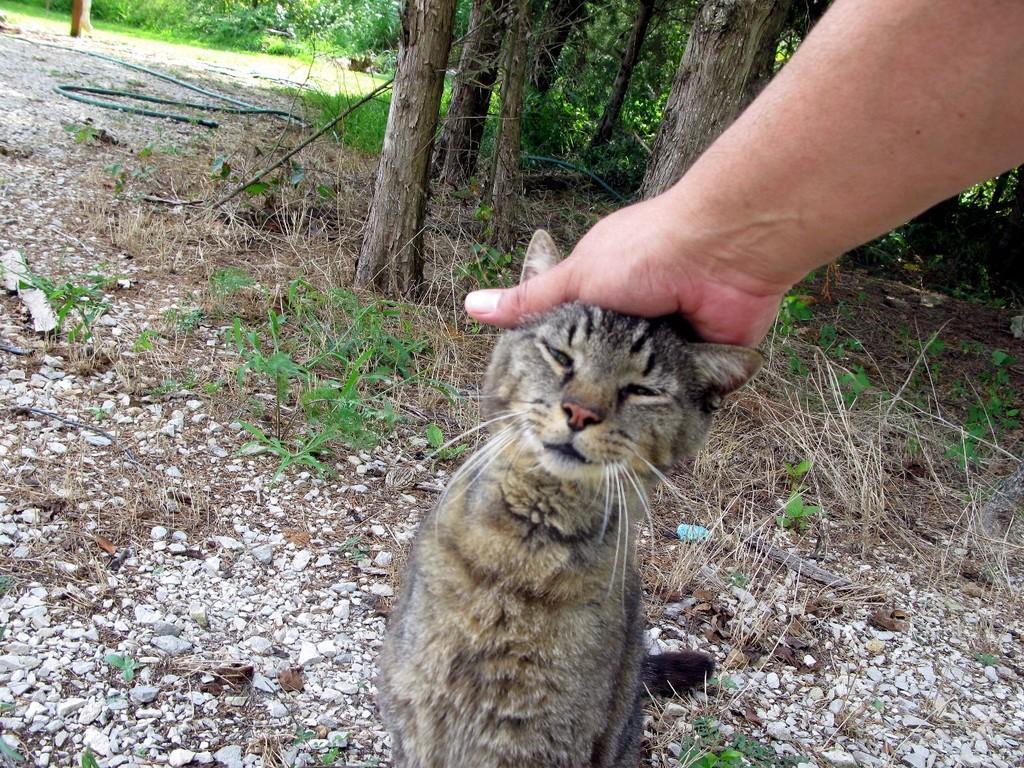Please provide a concise description of this image. In this image, we can see a cat is sitting. Here there is a person's hand on the cat head. Background we can see stones, plants, grass, trees and pipe. 